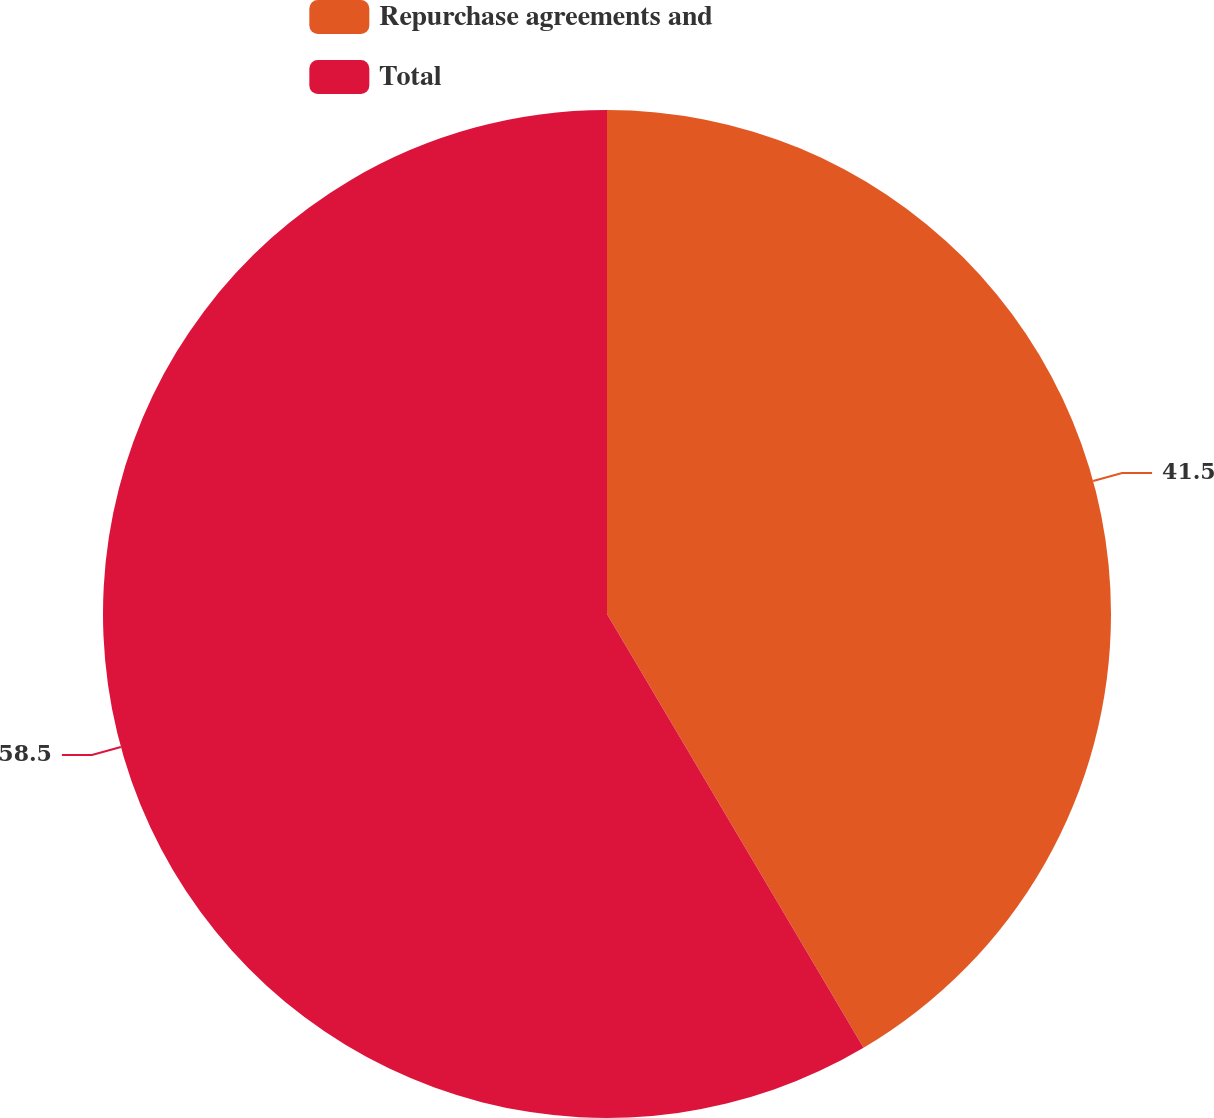<chart> <loc_0><loc_0><loc_500><loc_500><pie_chart><fcel>Repurchase agreements and<fcel>Total<nl><fcel>41.5%<fcel>58.5%<nl></chart> 